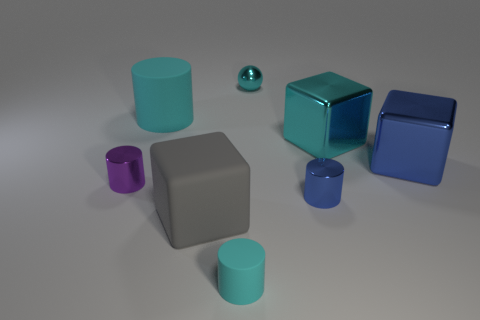Are there any other things that have the same shape as the small cyan metal thing?
Provide a short and direct response. No. What is the material of the large gray object that is the same shape as the big blue thing?
Give a very brief answer. Rubber. There is a blue object behind the purple cylinder; does it have the same shape as the large matte thing in front of the purple cylinder?
Provide a short and direct response. Yes. Are there fewer small cylinders that are on the right side of the tiny purple metallic cylinder than cyan things that are right of the gray thing?
Offer a very short reply. Yes. How many other objects are the same shape as the large cyan matte thing?
Your answer should be very brief. 3. There is a big cyan thing that is made of the same material as the small blue thing; what shape is it?
Your answer should be compact. Cube. There is a tiny cylinder that is both behind the small cyan cylinder and to the right of the small purple thing; what color is it?
Give a very brief answer. Blue. Are the tiny cylinder that is on the left side of the small cyan matte object and the big gray cube made of the same material?
Your answer should be compact. No. Are there fewer tiny cyan metal balls on the right side of the big cyan metallic object than green blocks?
Provide a short and direct response. No. Are there any large yellow spheres made of the same material as the large cyan block?
Keep it short and to the point. No. 